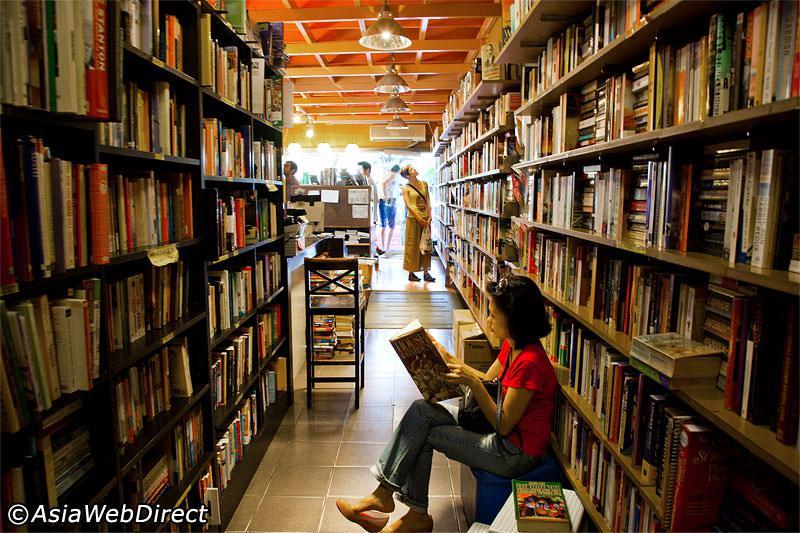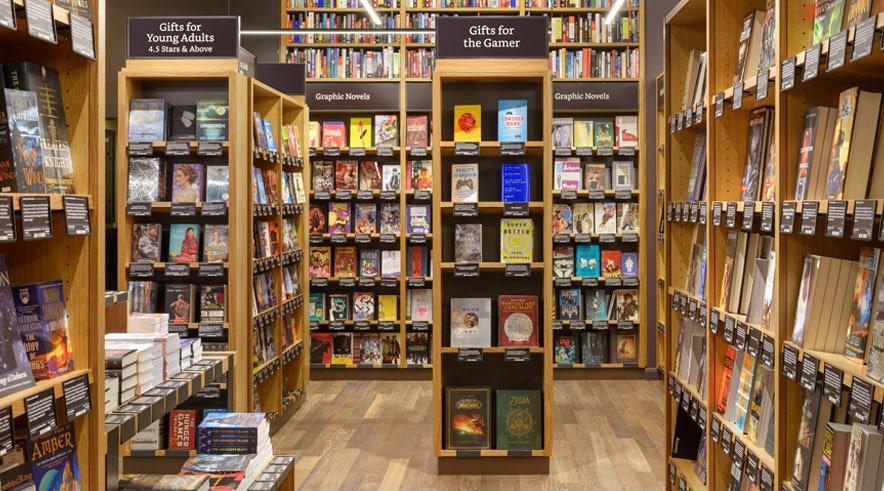The first image is the image on the left, the second image is the image on the right. Evaluate the accuracy of this statement regarding the images: "There are multiple people in a bookstore in the left image.". Is it true? Answer yes or no. Yes. 